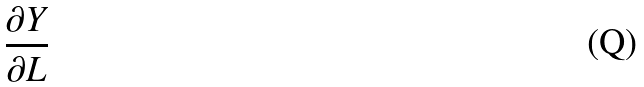Convert formula to latex. <formula><loc_0><loc_0><loc_500><loc_500>\frac { \partial Y } { \partial L }</formula> 